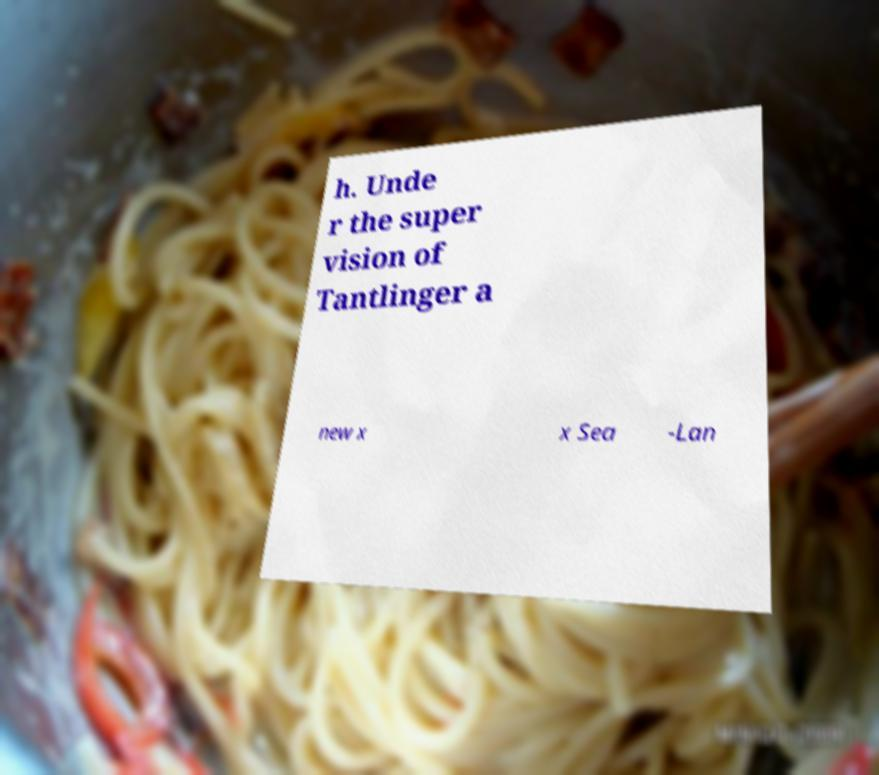Please identify and transcribe the text found in this image. h. Unde r the super vision of Tantlinger a new x x Sea -Lan 